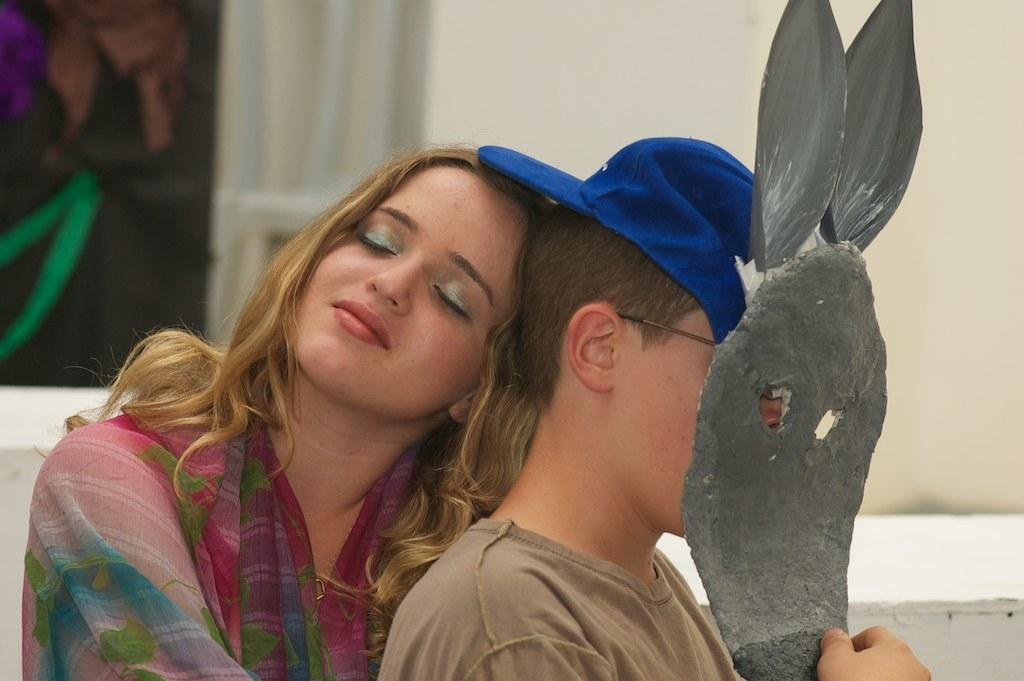Who is present in the image? There is a boy and a lady in the image. What is the boy holding in the image? The boy is holding a mask. What can be seen on the boy's head? The boy is wearing a blue color cap. What is visible in the background of the image? There is a wall in the background of the image. What type of clouds can be seen in the image? There are no clouds visible in the image; it only shows a boy, a lady, a wall, and the boy holding a mask and wearing a blue cap. 